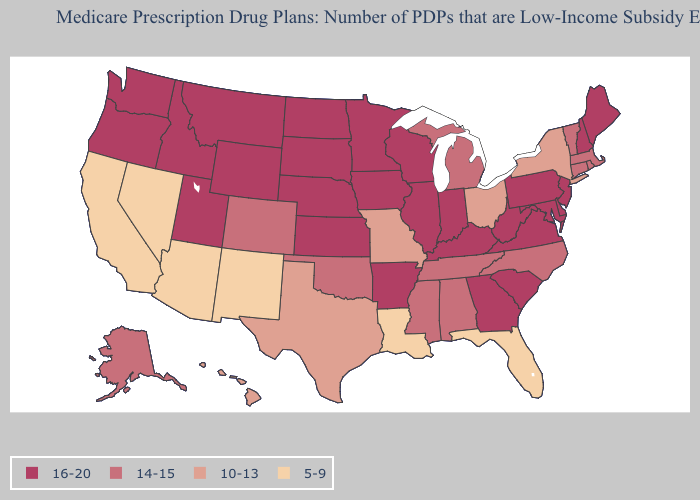Is the legend a continuous bar?
Keep it brief. No. What is the highest value in the Northeast ?
Write a very short answer. 16-20. Does Texas have the same value as Kansas?
Give a very brief answer. No. How many symbols are there in the legend?
Be succinct. 4. Name the states that have a value in the range 10-13?
Keep it brief. Hawaii, Missouri, New York, Ohio, Texas. Name the states that have a value in the range 14-15?
Answer briefly. Alaska, Alabama, Colorado, Connecticut, Massachusetts, Michigan, Mississippi, North Carolina, Oklahoma, Rhode Island, Tennessee, Vermont. Which states have the lowest value in the West?
Give a very brief answer. Arizona, California, New Mexico, Nevada. What is the lowest value in the USA?
Quick response, please. 5-9. Name the states that have a value in the range 10-13?
Be succinct. Hawaii, Missouri, New York, Ohio, Texas. Among the states that border New York , which have the highest value?
Quick response, please. New Jersey, Pennsylvania. What is the value of Montana?
Give a very brief answer. 16-20. Name the states that have a value in the range 5-9?
Answer briefly. Arizona, California, Florida, Louisiana, New Mexico, Nevada. Which states hav the highest value in the MidWest?
Write a very short answer. Iowa, Illinois, Indiana, Kansas, Minnesota, North Dakota, Nebraska, South Dakota, Wisconsin. Name the states that have a value in the range 16-20?
Give a very brief answer. Arkansas, Delaware, Georgia, Iowa, Idaho, Illinois, Indiana, Kansas, Kentucky, Maryland, Maine, Minnesota, Montana, North Dakota, Nebraska, New Hampshire, New Jersey, Oregon, Pennsylvania, South Carolina, South Dakota, Utah, Virginia, Washington, Wisconsin, West Virginia, Wyoming. Does New Hampshire have the highest value in the USA?
Answer briefly. Yes. 